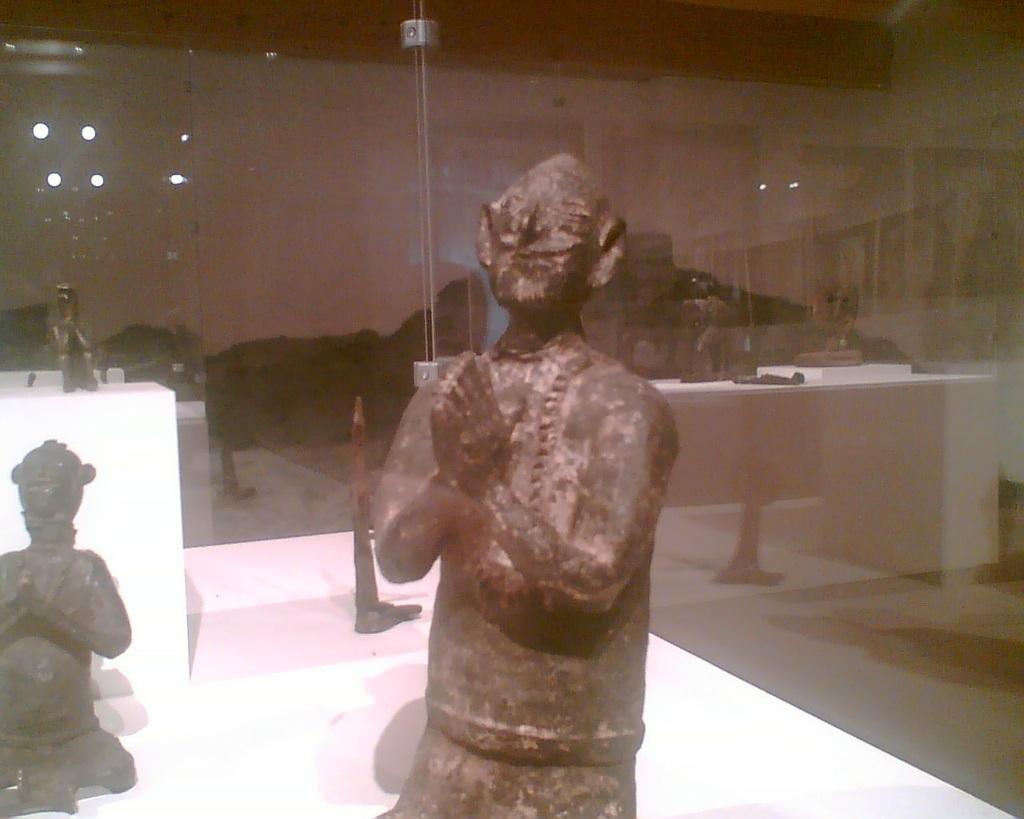How would you summarize this image in a sentence or two? In the center of the image there is a depiction of a person. In the background of the image there is glass. 